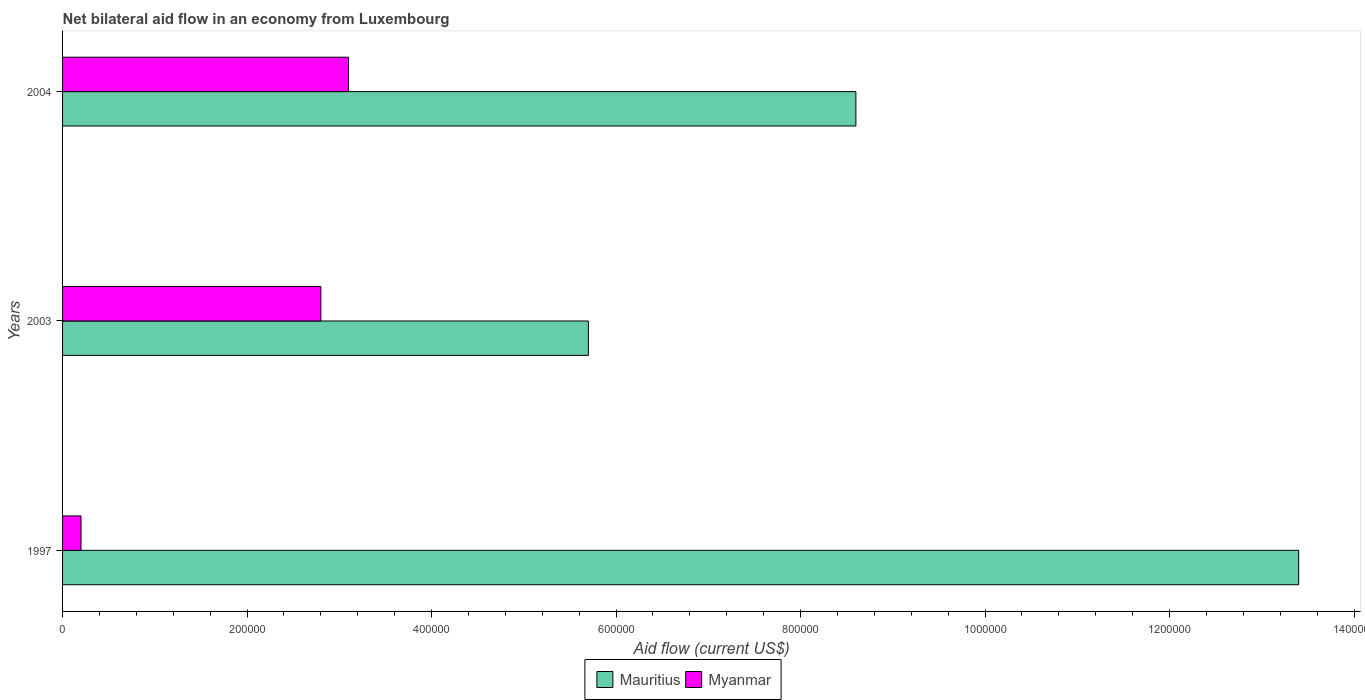How many different coloured bars are there?
Provide a succinct answer. 2. How many groups of bars are there?
Your answer should be compact. 3. Are the number of bars per tick equal to the number of legend labels?
Your answer should be compact. Yes. Are the number of bars on each tick of the Y-axis equal?
Your response must be concise. Yes. How many bars are there on the 2nd tick from the top?
Your answer should be very brief. 2. How many bars are there on the 1st tick from the bottom?
Keep it short and to the point. 2. What is the label of the 3rd group of bars from the top?
Ensure brevity in your answer.  1997. What is the net bilateral aid flow in Mauritius in 2004?
Your answer should be very brief. 8.60e+05. Across all years, what is the maximum net bilateral aid flow in Mauritius?
Provide a succinct answer. 1.34e+06. In which year was the net bilateral aid flow in Myanmar minimum?
Your response must be concise. 1997. What is the total net bilateral aid flow in Myanmar in the graph?
Provide a short and direct response. 6.10e+05. What is the difference between the net bilateral aid flow in Mauritius in 2004 and the net bilateral aid flow in Myanmar in 2003?
Offer a very short reply. 5.80e+05. What is the average net bilateral aid flow in Myanmar per year?
Ensure brevity in your answer.  2.03e+05. In the year 1997, what is the difference between the net bilateral aid flow in Myanmar and net bilateral aid flow in Mauritius?
Ensure brevity in your answer.  -1.32e+06. What is the ratio of the net bilateral aid flow in Myanmar in 1997 to that in 2003?
Provide a succinct answer. 0.07. Is the difference between the net bilateral aid flow in Myanmar in 1997 and 2004 greater than the difference between the net bilateral aid flow in Mauritius in 1997 and 2004?
Your answer should be very brief. No. What is the difference between the highest and the second highest net bilateral aid flow in Mauritius?
Provide a succinct answer. 4.80e+05. What is the difference between the highest and the lowest net bilateral aid flow in Mauritius?
Your answer should be very brief. 7.70e+05. In how many years, is the net bilateral aid flow in Myanmar greater than the average net bilateral aid flow in Myanmar taken over all years?
Give a very brief answer. 2. What does the 1st bar from the top in 1997 represents?
Offer a very short reply. Myanmar. What does the 2nd bar from the bottom in 2003 represents?
Provide a succinct answer. Myanmar. How many bars are there?
Offer a very short reply. 6. Are all the bars in the graph horizontal?
Make the answer very short. Yes. How many years are there in the graph?
Offer a very short reply. 3. What is the difference between two consecutive major ticks on the X-axis?
Provide a succinct answer. 2.00e+05. Does the graph contain grids?
Your answer should be compact. No. Where does the legend appear in the graph?
Make the answer very short. Bottom center. How many legend labels are there?
Your response must be concise. 2. What is the title of the graph?
Your answer should be compact. Net bilateral aid flow in an economy from Luxembourg. Does "Mexico" appear as one of the legend labels in the graph?
Offer a very short reply. No. What is the label or title of the X-axis?
Offer a terse response. Aid flow (current US$). What is the label or title of the Y-axis?
Give a very brief answer. Years. What is the Aid flow (current US$) in Mauritius in 1997?
Offer a terse response. 1.34e+06. What is the Aid flow (current US$) of Myanmar in 1997?
Make the answer very short. 2.00e+04. What is the Aid flow (current US$) in Mauritius in 2003?
Offer a terse response. 5.70e+05. What is the Aid flow (current US$) of Mauritius in 2004?
Provide a succinct answer. 8.60e+05. What is the Aid flow (current US$) in Myanmar in 2004?
Offer a terse response. 3.10e+05. Across all years, what is the maximum Aid flow (current US$) in Mauritius?
Keep it short and to the point. 1.34e+06. Across all years, what is the minimum Aid flow (current US$) in Mauritius?
Give a very brief answer. 5.70e+05. Across all years, what is the minimum Aid flow (current US$) of Myanmar?
Your answer should be compact. 2.00e+04. What is the total Aid flow (current US$) in Mauritius in the graph?
Keep it short and to the point. 2.77e+06. What is the difference between the Aid flow (current US$) of Mauritius in 1997 and that in 2003?
Your response must be concise. 7.70e+05. What is the difference between the Aid flow (current US$) in Myanmar in 1997 and that in 2004?
Offer a terse response. -2.90e+05. What is the difference between the Aid flow (current US$) of Mauritius in 2003 and that in 2004?
Provide a succinct answer. -2.90e+05. What is the difference between the Aid flow (current US$) in Mauritius in 1997 and the Aid flow (current US$) in Myanmar in 2003?
Keep it short and to the point. 1.06e+06. What is the difference between the Aid flow (current US$) in Mauritius in 1997 and the Aid flow (current US$) in Myanmar in 2004?
Ensure brevity in your answer.  1.03e+06. What is the difference between the Aid flow (current US$) in Mauritius in 2003 and the Aid flow (current US$) in Myanmar in 2004?
Ensure brevity in your answer.  2.60e+05. What is the average Aid flow (current US$) in Mauritius per year?
Give a very brief answer. 9.23e+05. What is the average Aid flow (current US$) in Myanmar per year?
Keep it short and to the point. 2.03e+05. In the year 1997, what is the difference between the Aid flow (current US$) in Mauritius and Aid flow (current US$) in Myanmar?
Offer a very short reply. 1.32e+06. In the year 2003, what is the difference between the Aid flow (current US$) of Mauritius and Aid flow (current US$) of Myanmar?
Make the answer very short. 2.90e+05. What is the ratio of the Aid flow (current US$) in Mauritius in 1997 to that in 2003?
Keep it short and to the point. 2.35. What is the ratio of the Aid flow (current US$) of Myanmar in 1997 to that in 2003?
Your response must be concise. 0.07. What is the ratio of the Aid flow (current US$) in Mauritius in 1997 to that in 2004?
Keep it short and to the point. 1.56. What is the ratio of the Aid flow (current US$) of Myanmar in 1997 to that in 2004?
Make the answer very short. 0.06. What is the ratio of the Aid flow (current US$) of Mauritius in 2003 to that in 2004?
Your answer should be compact. 0.66. What is the ratio of the Aid flow (current US$) in Myanmar in 2003 to that in 2004?
Your response must be concise. 0.9. What is the difference between the highest and the lowest Aid flow (current US$) of Mauritius?
Provide a succinct answer. 7.70e+05. What is the difference between the highest and the lowest Aid flow (current US$) in Myanmar?
Give a very brief answer. 2.90e+05. 